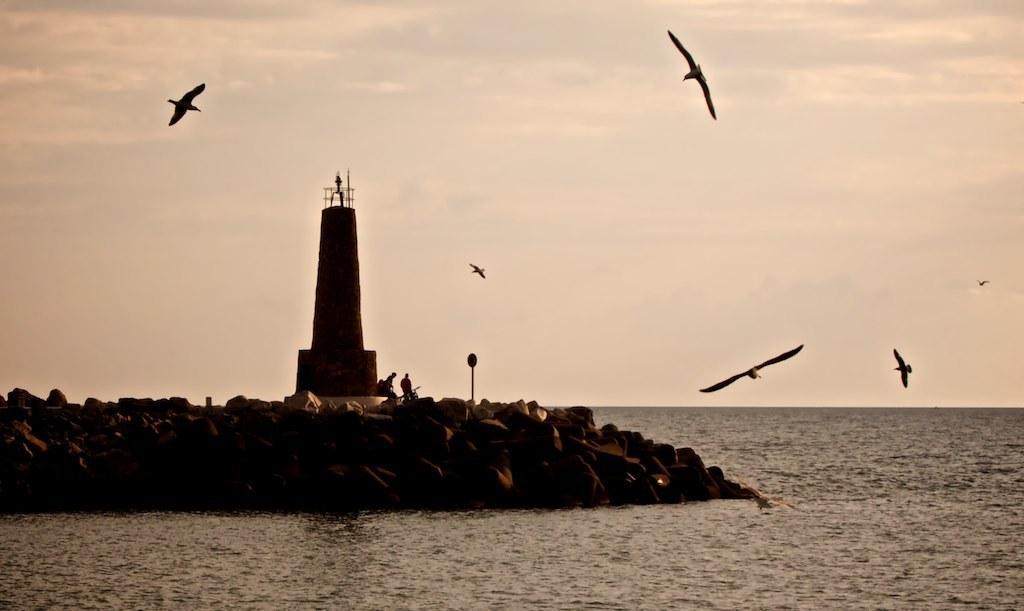Please provide a concise description of this image. In this image there is the sky towards the top of the image, there are birds flying, there is a tower, there are two men sitting, there are rocks towards the left of the image, there is a pole, there is a board, there is water towards the bottom of the image. 